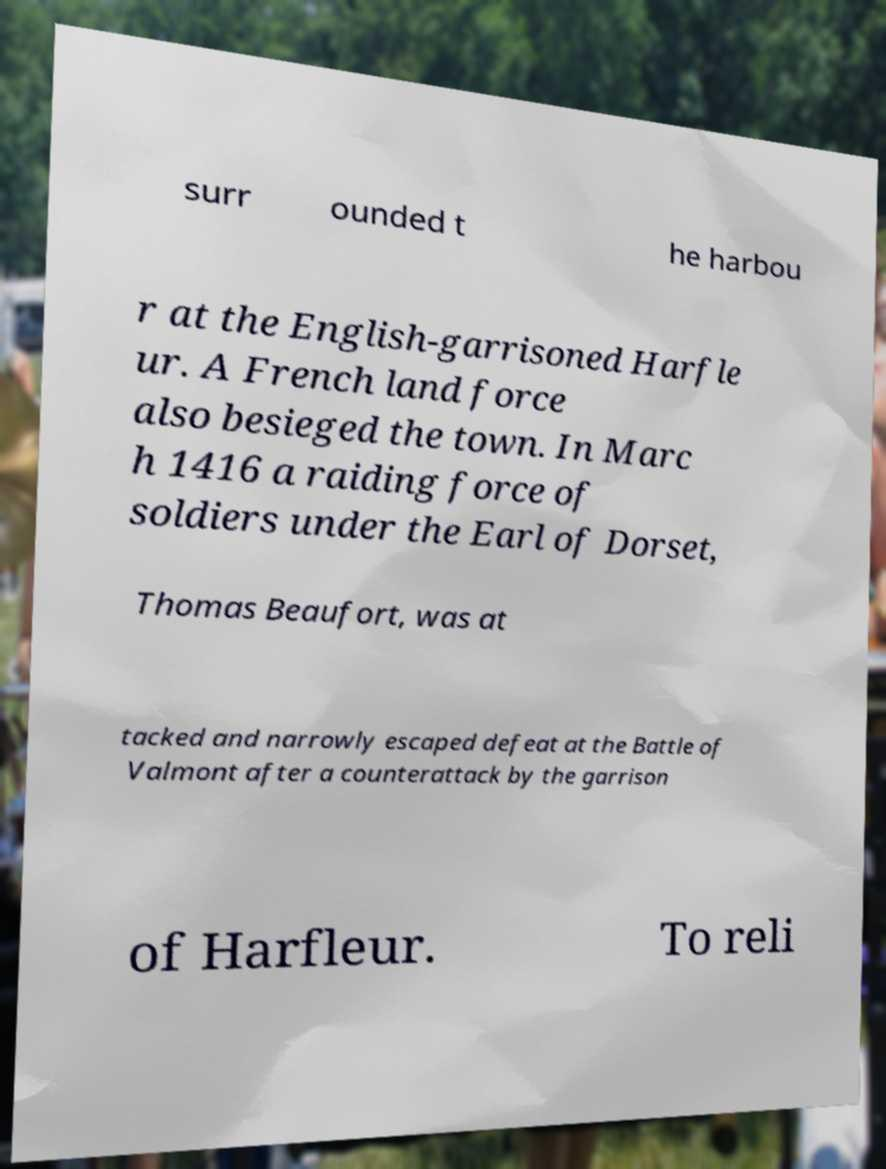Could you extract and type out the text from this image? surr ounded t he harbou r at the English-garrisoned Harfle ur. A French land force also besieged the town. In Marc h 1416 a raiding force of soldiers under the Earl of Dorset, Thomas Beaufort, was at tacked and narrowly escaped defeat at the Battle of Valmont after a counterattack by the garrison of Harfleur. To reli 